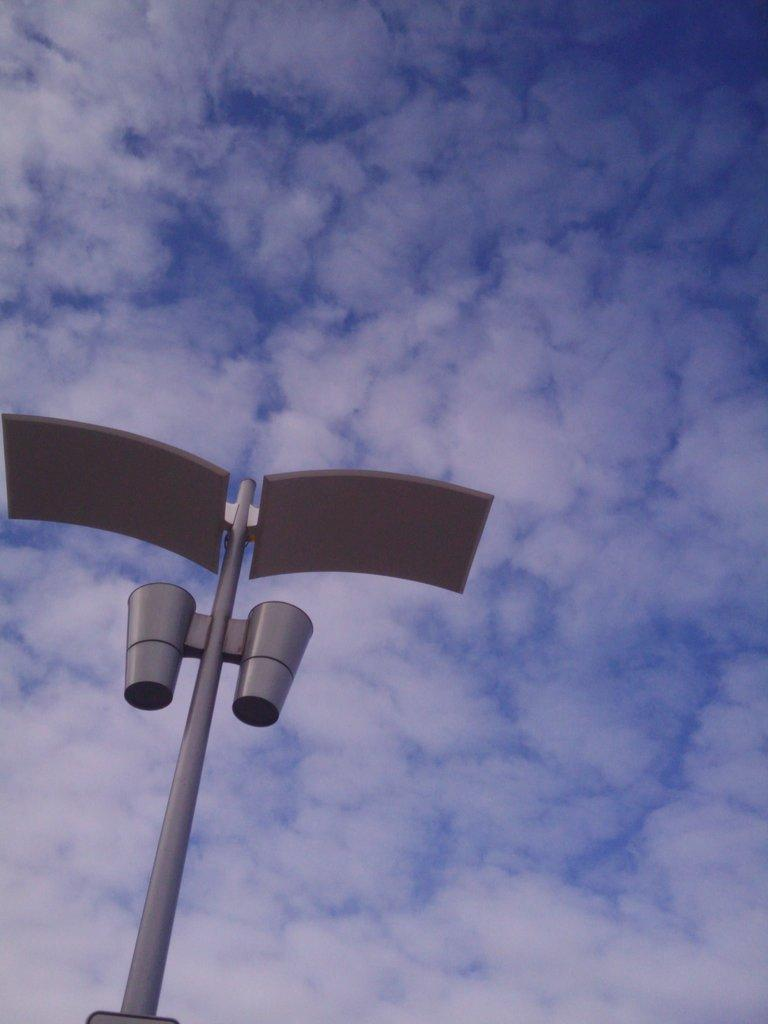What is the main object in the image? There is a pole in the image. What can be seen in the sky in the image? Clouds are visible in the image. What else is visible in the image besides the pole and clouds? The sky is visible in the image. What type of business is being conducted at the top of the pole in the image? There is no indication of any business being conducted in the image, as it only features a pole and clouds. What is the cork used for in the image? There is no cork present in the image. 